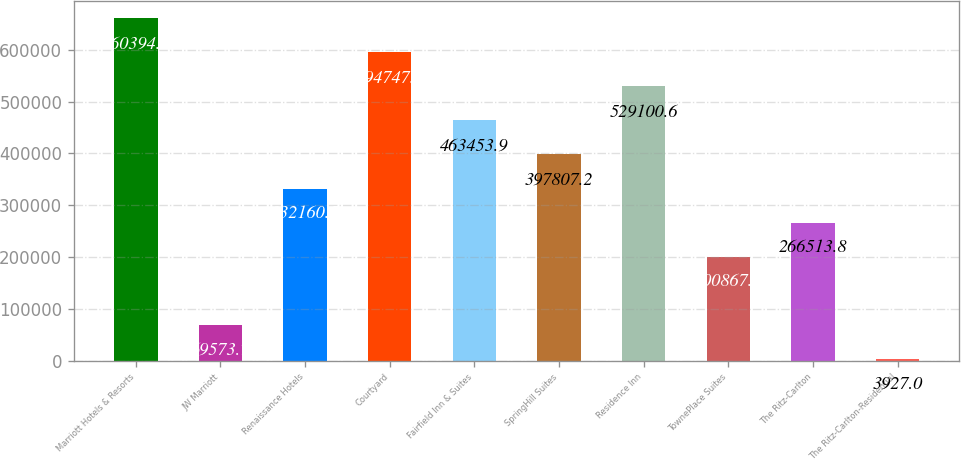Convert chart. <chart><loc_0><loc_0><loc_500><loc_500><bar_chart><fcel>Marriott Hotels & Resorts<fcel>JW Marriott<fcel>Renaissance Hotels<fcel>Courtyard<fcel>Fairfield Inn & Suites<fcel>SpringHill Suites<fcel>Residence Inn<fcel>TownePlace Suites<fcel>The Ritz-Carlton<fcel>The Ritz-Carlton-Residential<nl><fcel>660394<fcel>69573.7<fcel>332160<fcel>594747<fcel>463454<fcel>397807<fcel>529101<fcel>200867<fcel>266514<fcel>3927<nl></chart> 